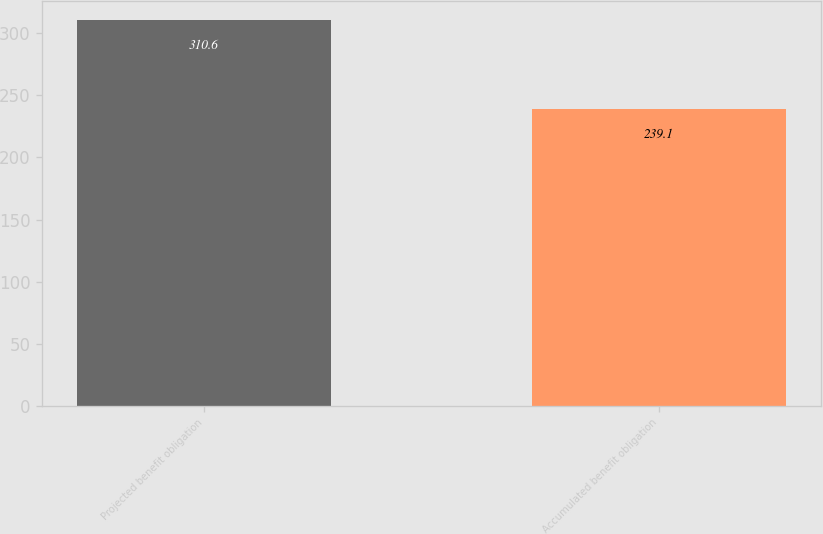Convert chart to OTSL. <chart><loc_0><loc_0><loc_500><loc_500><bar_chart><fcel>Projected benefit obligation<fcel>Accumulated benefit obligation<nl><fcel>310.6<fcel>239.1<nl></chart> 